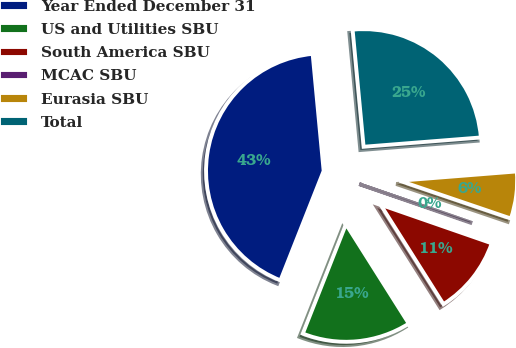<chart> <loc_0><loc_0><loc_500><loc_500><pie_chart><fcel>Year Ended December 31<fcel>US and Utilities SBU<fcel>South America SBU<fcel>MCAC SBU<fcel>Eurasia SBU<fcel>Total<nl><fcel>42.52%<fcel>14.95%<fcel>10.71%<fcel>0.11%<fcel>6.47%<fcel>25.23%<nl></chart> 